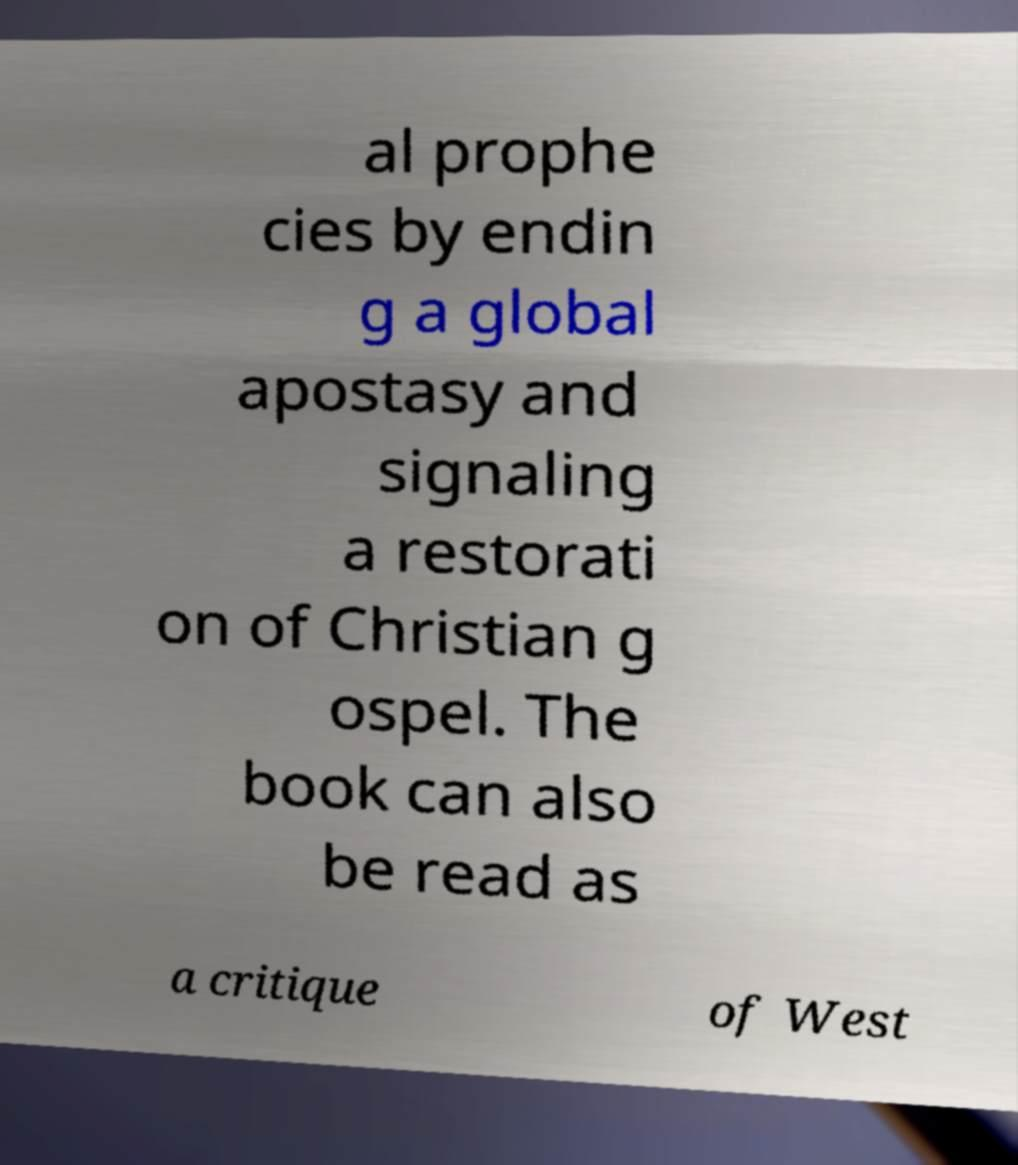What messages or text are displayed in this image? I need them in a readable, typed format. al prophe cies by endin g a global apostasy and signaling a restorati on of Christian g ospel. The book can also be read as a critique of West 